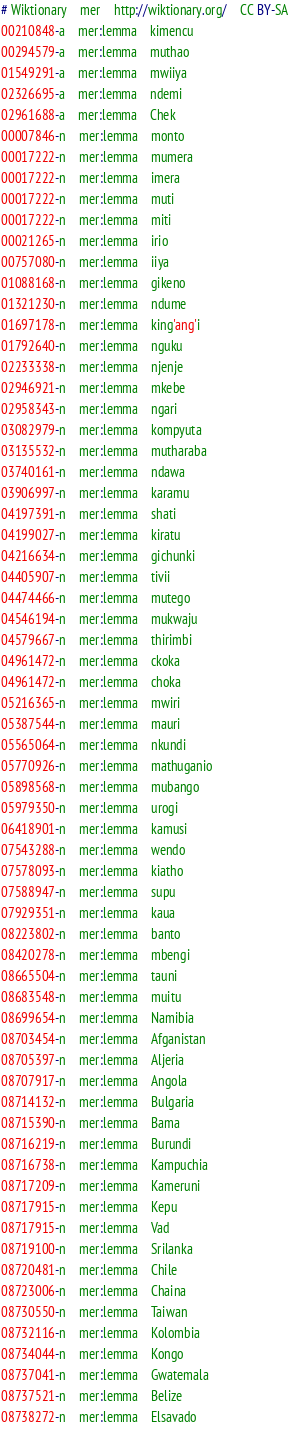<code> <loc_0><loc_0><loc_500><loc_500><_SQL_># Wiktionary	mer	http://wiktionary.org/	CC BY-SA
00210848-a	mer:lemma	kimencu
00294579-a	mer:lemma	muthao
01549291-a	mer:lemma	mwiiya
02326695-a	mer:lemma	ndemi
02961688-a	mer:lemma	Chek
00007846-n	mer:lemma	monto
00017222-n	mer:lemma	mumera
00017222-n	mer:lemma	imera
00017222-n	mer:lemma	muti
00017222-n	mer:lemma	miti
00021265-n	mer:lemma	irio
00757080-n	mer:lemma	iiya
01088168-n	mer:lemma	gikeno
01321230-n	mer:lemma	ndume
01697178-n	mer:lemma	king'ang'i
01792640-n	mer:lemma	nguku
02233338-n	mer:lemma	njenje
02946921-n	mer:lemma	mkebe
02958343-n	mer:lemma	ngari
03082979-n	mer:lemma	kompyuta
03135532-n	mer:lemma	mutharaba
03740161-n	mer:lemma	ndawa
03906997-n	mer:lemma	karamu
04197391-n	mer:lemma	shati
04199027-n	mer:lemma	kiratu
04216634-n	mer:lemma	gichunki
04405907-n	mer:lemma	tivii
04474466-n	mer:lemma	mutego
04546194-n	mer:lemma	mukwaju
04579667-n	mer:lemma	thirimbi
04961472-n	mer:lemma	ckoka
04961472-n	mer:lemma	choka
05216365-n	mer:lemma	mwiri
05387544-n	mer:lemma	mauri
05565064-n	mer:lemma	nkundi
05770926-n	mer:lemma	mathuganio
05898568-n	mer:lemma	mubango
05979350-n	mer:lemma	urogi
06418901-n	mer:lemma	kamusi
07543288-n	mer:lemma	wendo
07578093-n	mer:lemma	kiatho
07588947-n	mer:lemma	supu
07929351-n	mer:lemma	kaua
08223802-n	mer:lemma	banto
08420278-n	mer:lemma	mbengi
08665504-n	mer:lemma	tauni
08683548-n	mer:lemma	muitu
08699654-n	mer:lemma	Namibia
08703454-n	mer:lemma	Afganistan
08705397-n	mer:lemma	Aljeria
08707917-n	mer:lemma	Angola
08714132-n	mer:lemma	Bulgaria
08715390-n	mer:lemma	Bama
08716219-n	mer:lemma	Burundi
08716738-n	mer:lemma	Kampuchia
08717209-n	mer:lemma	Kameruni
08717915-n	mer:lemma	Kepu
08717915-n	mer:lemma	Vad
08719100-n	mer:lemma	Srilanka
08720481-n	mer:lemma	Chile
08723006-n	mer:lemma	Chaina
08730550-n	mer:lemma	Taiwan
08732116-n	mer:lemma	Kolombia
08734044-n	mer:lemma	Kongo
08737041-n	mer:lemma	Gwatemala
08737521-n	mer:lemma	Belize
08738272-n	mer:lemma	Elsavado</code> 